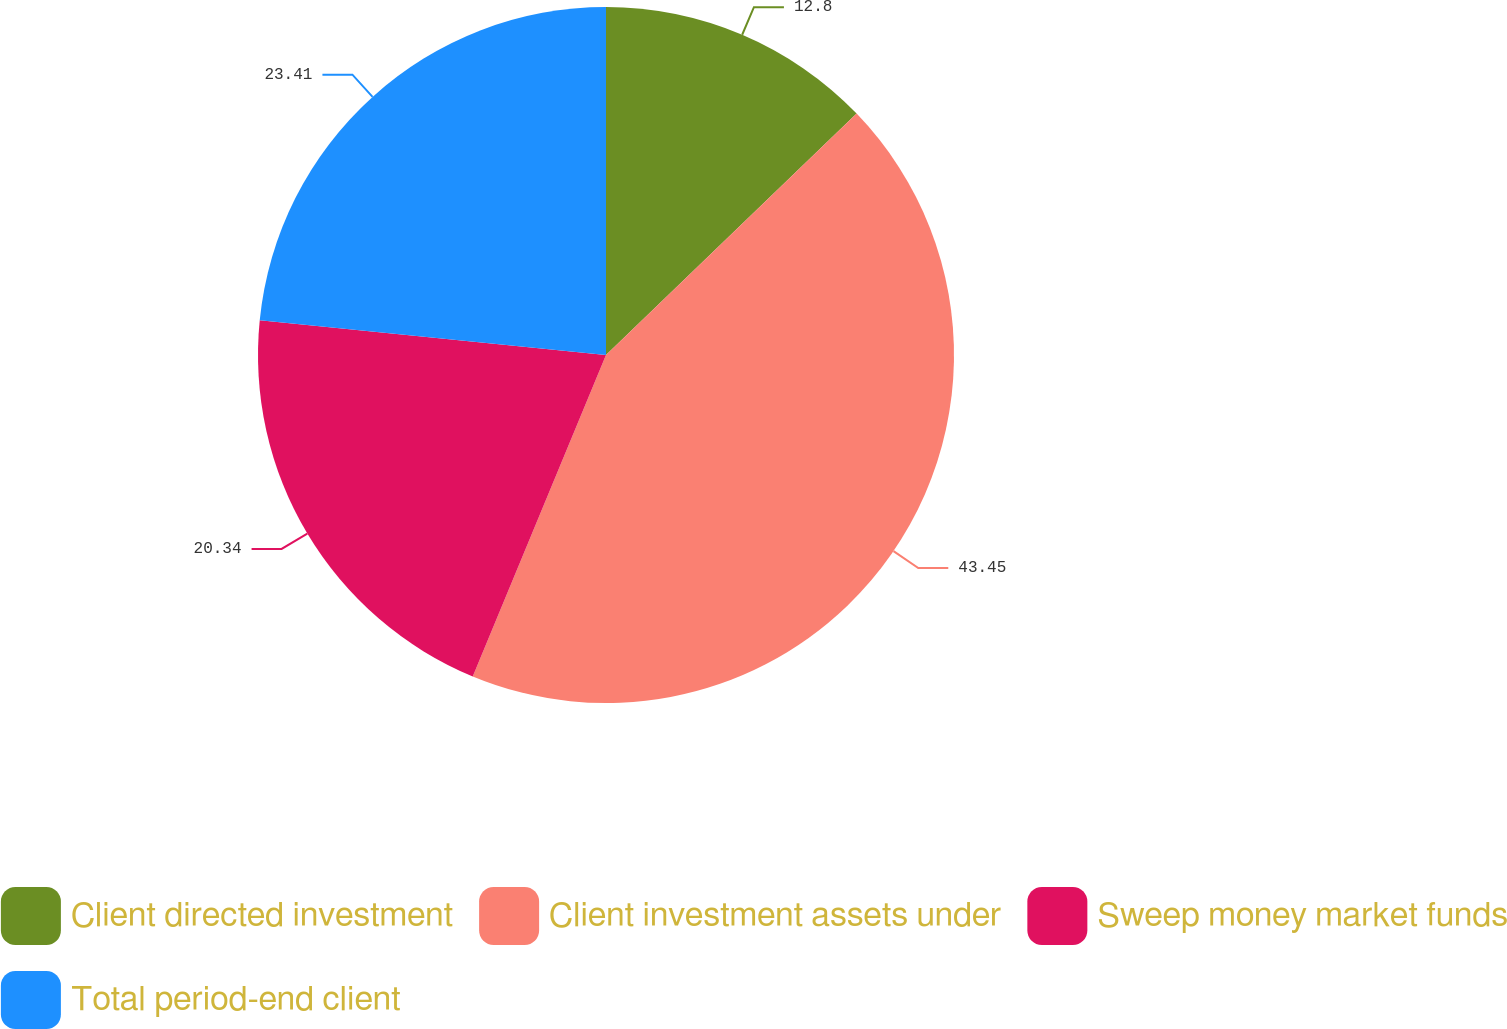Convert chart to OTSL. <chart><loc_0><loc_0><loc_500><loc_500><pie_chart><fcel>Client directed investment<fcel>Client investment assets under<fcel>Sweep money market funds<fcel>Total period-end client<nl><fcel>12.8%<fcel>43.46%<fcel>20.34%<fcel>23.41%<nl></chart> 